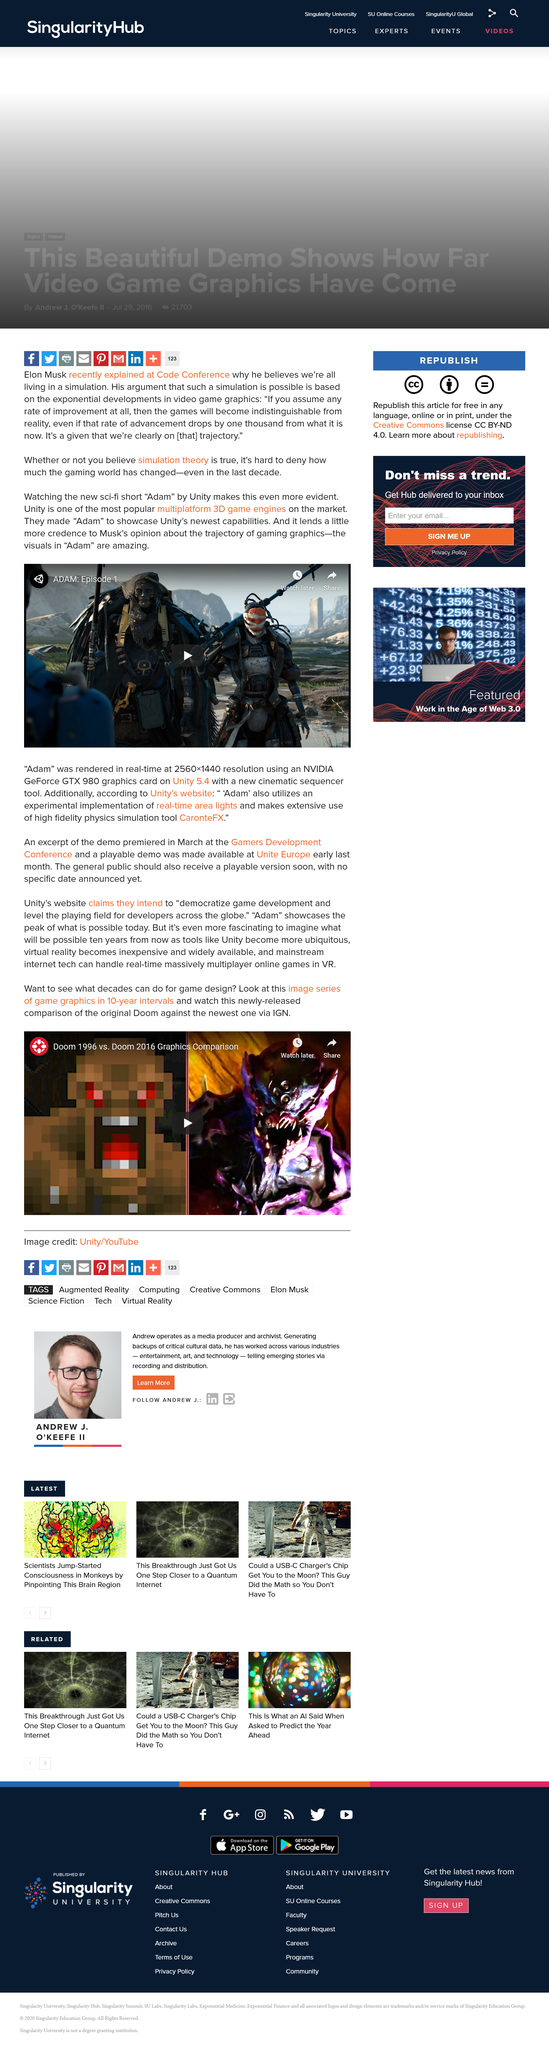Specify some key components in this picture. The short film made by Unity called Adam is a new Sci-Fi. Unity is widely recognized as one of the leading multiplatform 3D game engines, with a vast and active community of developers and users. The use of an NVIDIA GeForce GTX980 graphics card was integral to the production of the film Adam. 